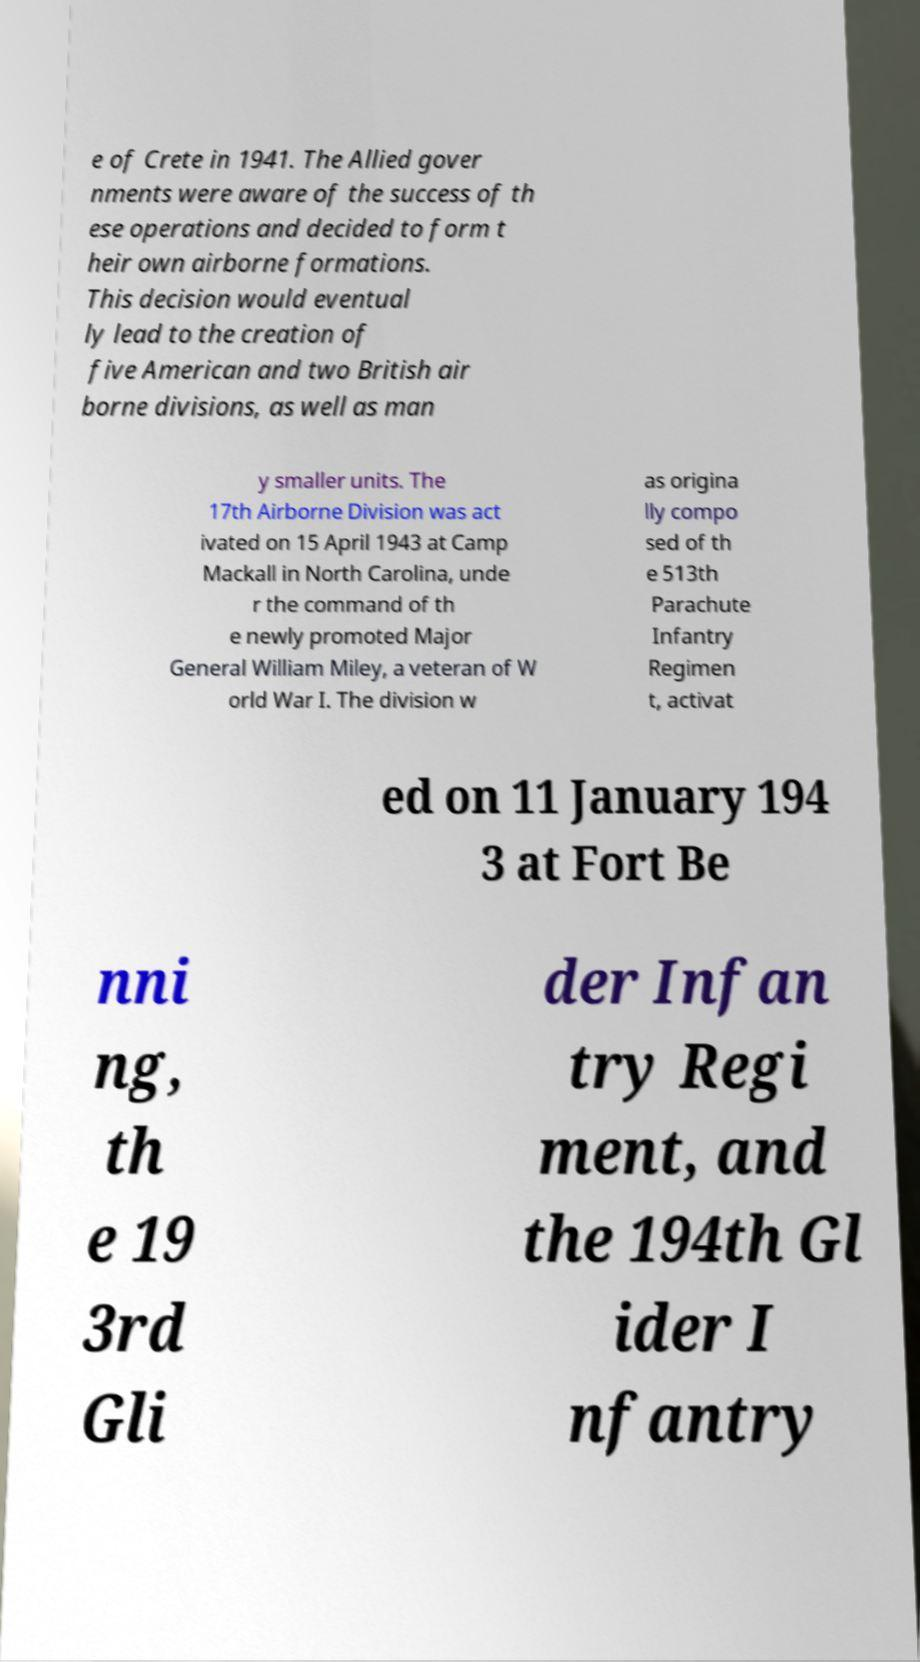Please read and relay the text visible in this image. What does it say? e of Crete in 1941. The Allied gover nments were aware of the success of th ese operations and decided to form t heir own airborne formations. This decision would eventual ly lead to the creation of five American and two British air borne divisions, as well as man y smaller units. The 17th Airborne Division was act ivated on 15 April 1943 at Camp Mackall in North Carolina, unde r the command of th e newly promoted Major General William Miley, a veteran of W orld War I. The division w as origina lly compo sed of th e 513th Parachute Infantry Regimen t, activat ed on 11 January 194 3 at Fort Be nni ng, th e 19 3rd Gli der Infan try Regi ment, and the 194th Gl ider I nfantry 